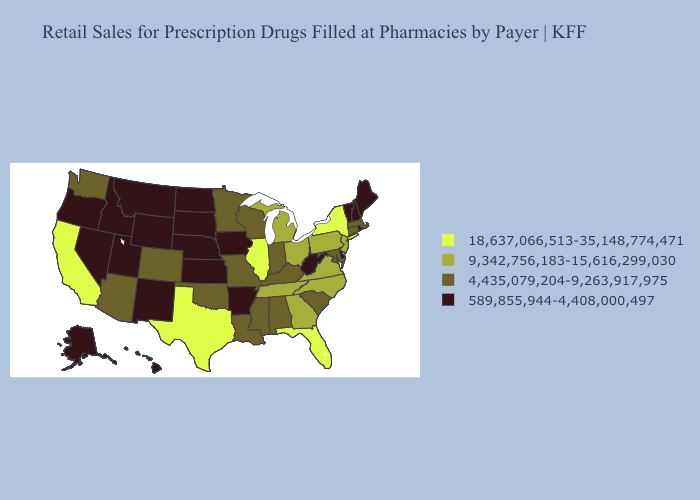What is the value of Mississippi?
Quick response, please. 4,435,079,204-9,263,917,975. What is the lowest value in states that border Iowa?
Short answer required. 589,855,944-4,408,000,497. What is the highest value in the Northeast ?
Answer briefly. 18,637,066,513-35,148,774,471. Among the states that border New Jersey , which have the highest value?
Write a very short answer. New York. Name the states that have a value in the range 18,637,066,513-35,148,774,471?
Short answer required. California, Florida, Illinois, New York, Texas. Does Florida have the highest value in the USA?
Give a very brief answer. Yes. What is the lowest value in the West?
Quick response, please. 589,855,944-4,408,000,497. What is the lowest value in states that border Nebraska?
Quick response, please. 589,855,944-4,408,000,497. What is the value of New Hampshire?
Be succinct. 589,855,944-4,408,000,497. Name the states that have a value in the range 18,637,066,513-35,148,774,471?
Short answer required. California, Florida, Illinois, New York, Texas. Among the states that border Virginia , which have the highest value?
Keep it brief. North Carolina, Tennessee. What is the highest value in the West ?
Write a very short answer. 18,637,066,513-35,148,774,471. Name the states that have a value in the range 589,855,944-4,408,000,497?
Be succinct. Alaska, Arkansas, Delaware, Hawaii, Idaho, Iowa, Kansas, Maine, Montana, Nebraska, Nevada, New Hampshire, New Mexico, North Dakota, Oregon, Rhode Island, South Dakota, Utah, Vermont, West Virginia, Wyoming. What is the value of Missouri?
Give a very brief answer. 4,435,079,204-9,263,917,975. What is the value of South Dakota?
Quick response, please. 589,855,944-4,408,000,497. 